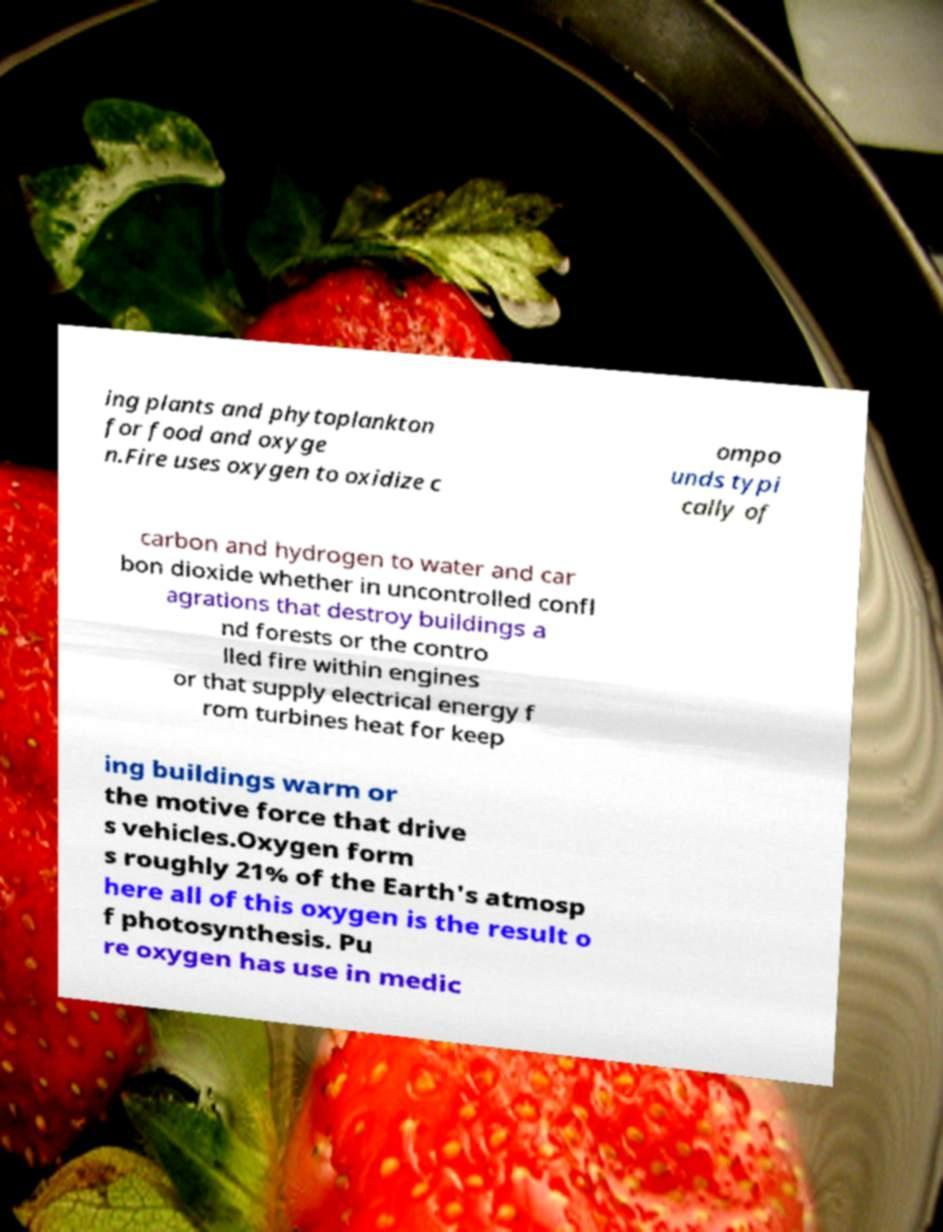I need the written content from this picture converted into text. Can you do that? ing plants and phytoplankton for food and oxyge n.Fire uses oxygen to oxidize c ompo unds typi cally of carbon and hydrogen to water and car bon dioxide whether in uncontrolled confl agrations that destroy buildings a nd forests or the contro lled fire within engines or that supply electrical energy f rom turbines heat for keep ing buildings warm or the motive force that drive s vehicles.Oxygen form s roughly 21% of the Earth's atmosp here all of this oxygen is the result o f photosynthesis. Pu re oxygen has use in medic 